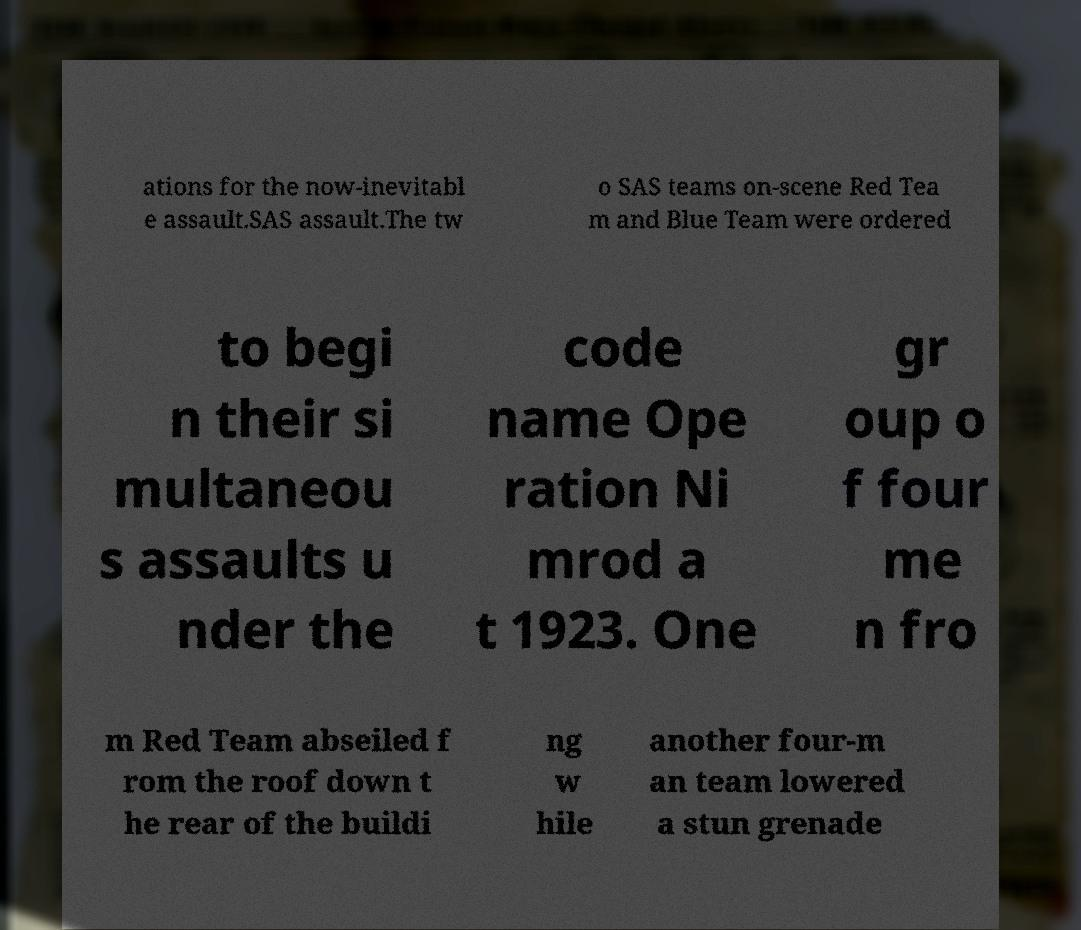What messages or text are displayed in this image? I need them in a readable, typed format. ations for the now-inevitabl e assault.SAS assault.The tw o SAS teams on-scene Red Tea m and Blue Team were ordered to begi n their si multaneou s assaults u nder the code name Ope ration Ni mrod a t 1923. One gr oup o f four me n fro m Red Team abseiled f rom the roof down t he rear of the buildi ng w hile another four-m an team lowered a stun grenade 